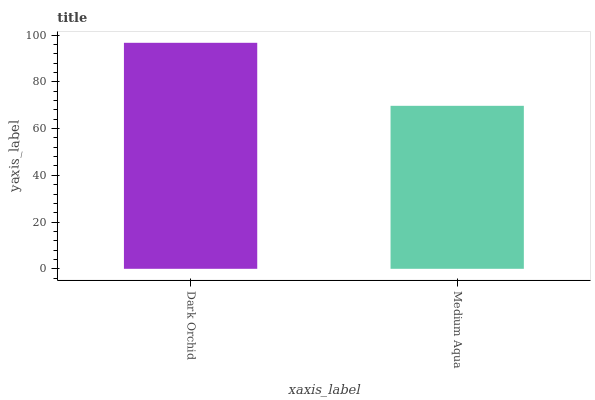Is Medium Aqua the maximum?
Answer yes or no. No. Is Dark Orchid greater than Medium Aqua?
Answer yes or no. Yes. Is Medium Aqua less than Dark Orchid?
Answer yes or no. Yes. Is Medium Aqua greater than Dark Orchid?
Answer yes or no. No. Is Dark Orchid less than Medium Aqua?
Answer yes or no. No. Is Dark Orchid the high median?
Answer yes or no. Yes. Is Medium Aqua the low median?
Answer yes or no. Yes. Is Medium Aqua the high median?
Answer yes or no. No. Is Dark Orchid the low median?
Answer yes or no. No. 